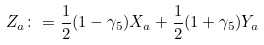Convert formula to latex. <formula><loc_0><loc_0><loc_500><loc_500>Z _ { a } \colon = \frac { 1 } { 2 } ( 1 - \gamma _ { 5 } ) X _ { a } + \frac { 1 } { 2 } ( 1 + \gamma _ { 5 } ) Y _ { a }</formula> 